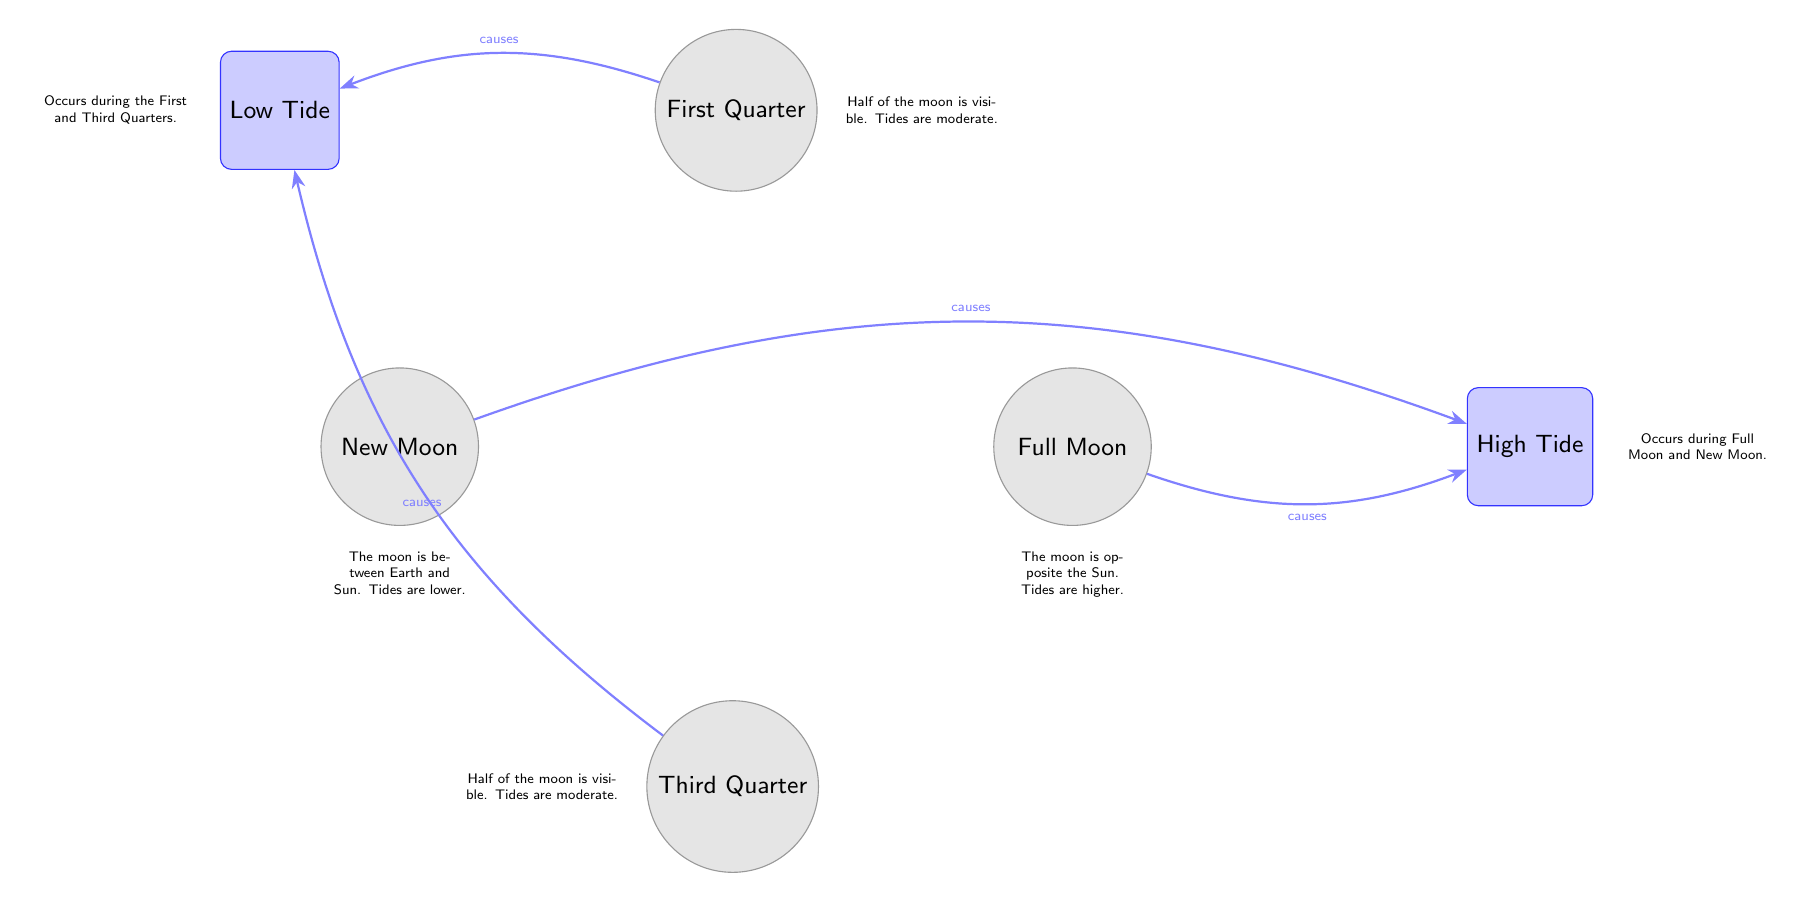What are the two types of tides caused by the moon phases? The diagram indicates that there are two types of tides: High Tide and Low Tide. These are specifically labeled in the diagram.
Answer: High Tide and Low Tide What moon phase is associated with High Tide? The diagram shows that both the New Moon and Full Moon cause High Tide. The arrows pointing from these moon phases to High Tide indicate this relationship.
Answer: New Moon and Full Moon Which moon phases result in Low Tide? According to the diagram, the First Quarter and Third Quarter moon phases are associated with Low Tide, as indicated by the arrows pointing to Low Tide from these phases.
Answer: First Quarter and Third Quarter How many moon phases are represented in the diagram? The diagram has a total of four moon phases: New Moon, First Quarter, Full Moon, and Third Quarter. By counting the moon nodes, we arrive at this total.
Answer: Four What effect does the New Moon have on tides? The diagram states that during a New Moon, tides are lower. This information is directly provided alongside the New Moon node in the diagram, giving a clear description of its effect.
Answer: Lower Which moon phase has the highest tides? The diagram indicates that the Full Moon causes the highest tides, as it points to High Tide with the label indicating this effect.
Answer: Full Moon What occurs during the First and Third Quarters in relation to tides? The diagram notes that during the First and Third Quarters, Low Tide occurs. This relationship is established through the arrows connecting these phases to the Low Tide node.
Answer: Low Tide What describes the visibility of the moon during the First Quarter? The diagram specifies that during the First Quarter, "Half of the moon is visible," which is provided as a description next to the First Quarter node.
Answer: Half of the moon is visible How are High Tides described in terms of their occurrence? The diagram mentions that High Tides occur during both the Full Moon and New Moon phases, indicating this relationship with a label next to the High Tide.
Answer: Occurs during Full Moon and New Moon 